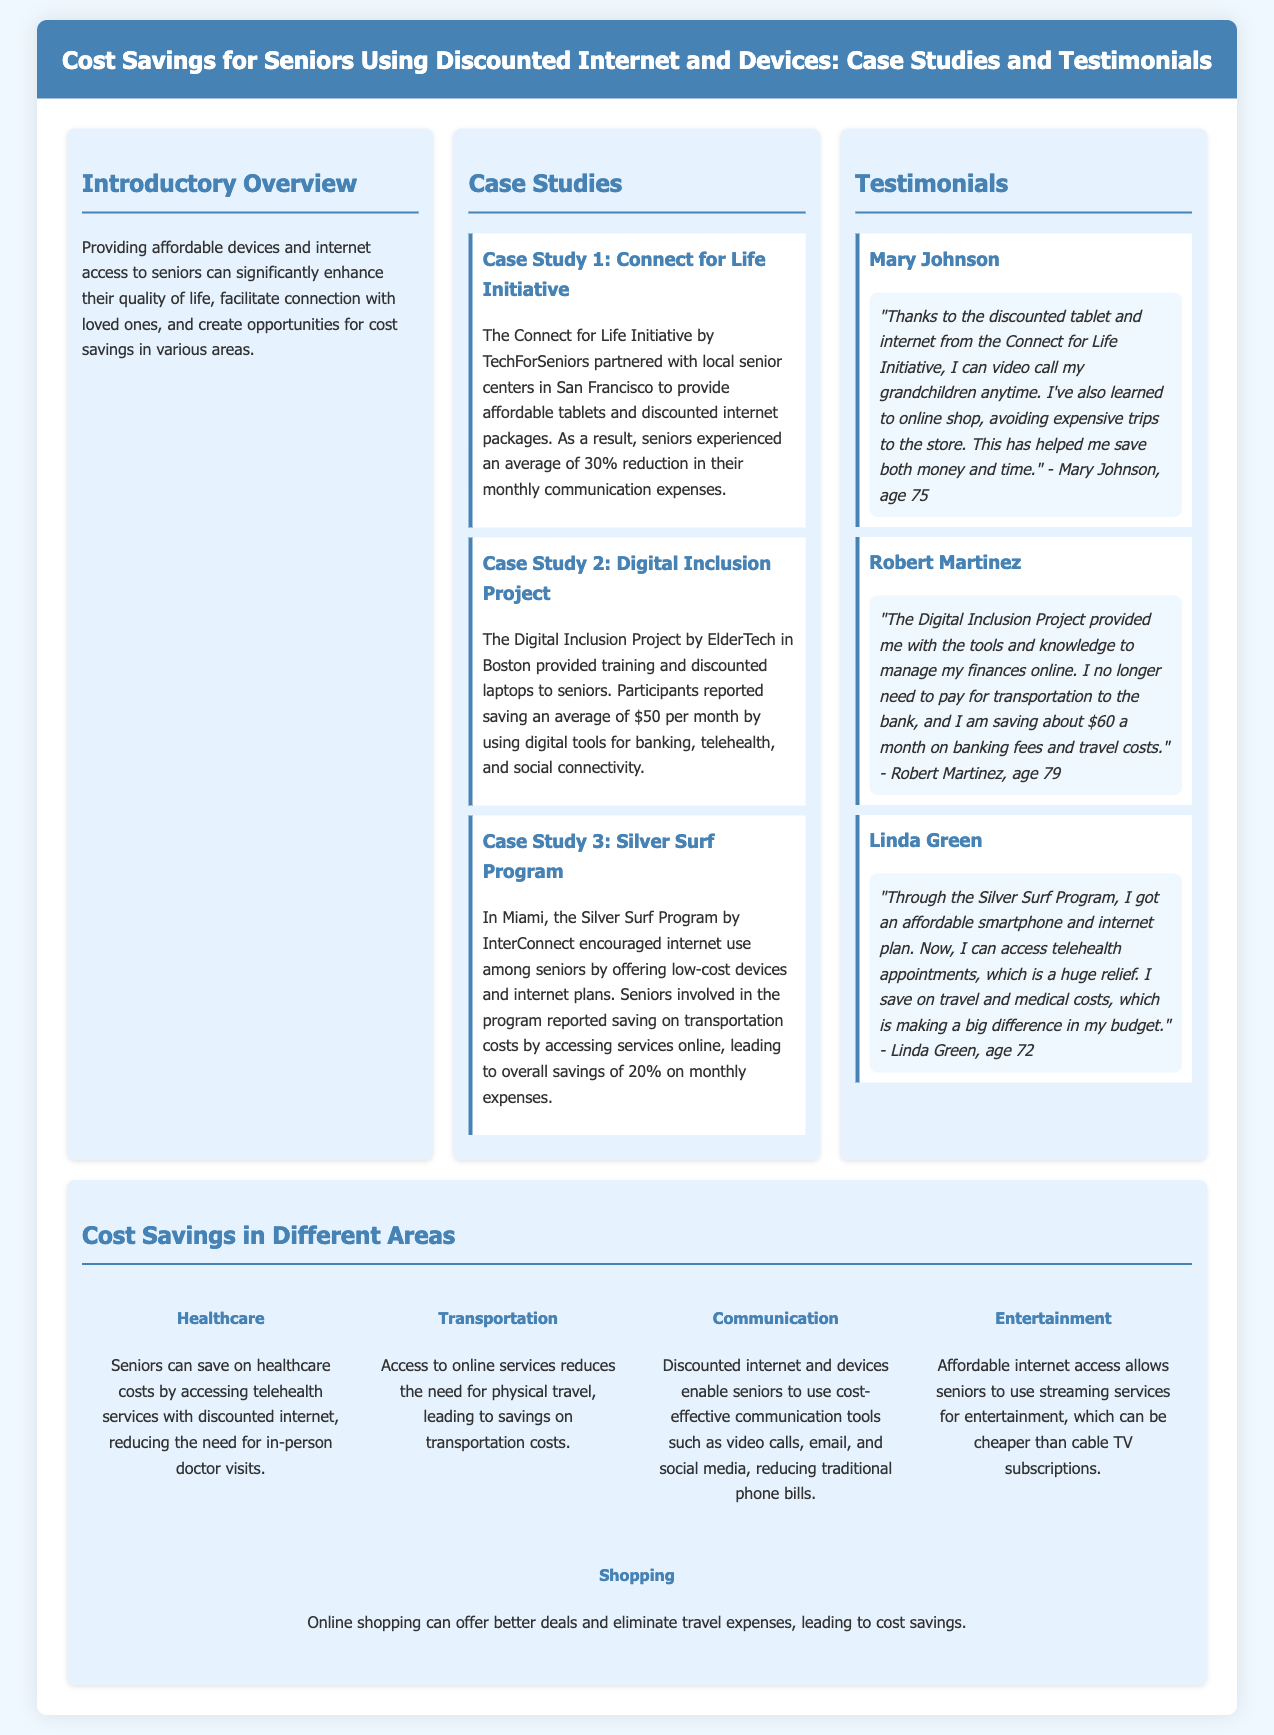What was the average reduction in monthly communication expenses from the Connect for Life Initiative? The document states that seniors experienced an average of 30% reduction in their monthly communication expenses due to the initiative.
Answer: 30% How much do participants in the Digital Inclusion Project report saving each month? According to the document, participants reported saving an average of $50 per month by using digital tools.
Answer: $50 What is the main benefit of the Silver Surf Program mentioned in the document? The main benefit of the Silver Surf Program is that it encouraged internet use among seniors, leading to overall savings of 20% on monthly expenses.
Answer: 20% What are the five different areas of cost savings for seniors mentioned in the document? The document outlines savings in healthcare, transportation, communication, entertainment, and shopping.
Answer: healthcare, transportation, communication, entertainment, shopping Who is the age 75 testimonial provider in the document? The provided testimonial from age 75 is from Mary Johnson who shared her positive experience regarding the discounted tablet and internet.
Answer: Mary Johnson How much is Robert Martinez saving per month due to his online banking activities? Robert Martinez mentioned that he is saving about $60 a month on banking fees and travel costs as a result of managing his finances online.
Answer: $60 Which initiative provided low-cost devices and internet plans in Miami? The initiative referred to in Miami that provided low-cost devices and internet plans is the Silver Surf Program.
Answer: Silver Surf Program What type of services can seniors access online to save healthcare costs? Seniors can access telehealth services online, which helps in reducing the need for in-person doctor visits and saves costs.
Answer: telehealth services 